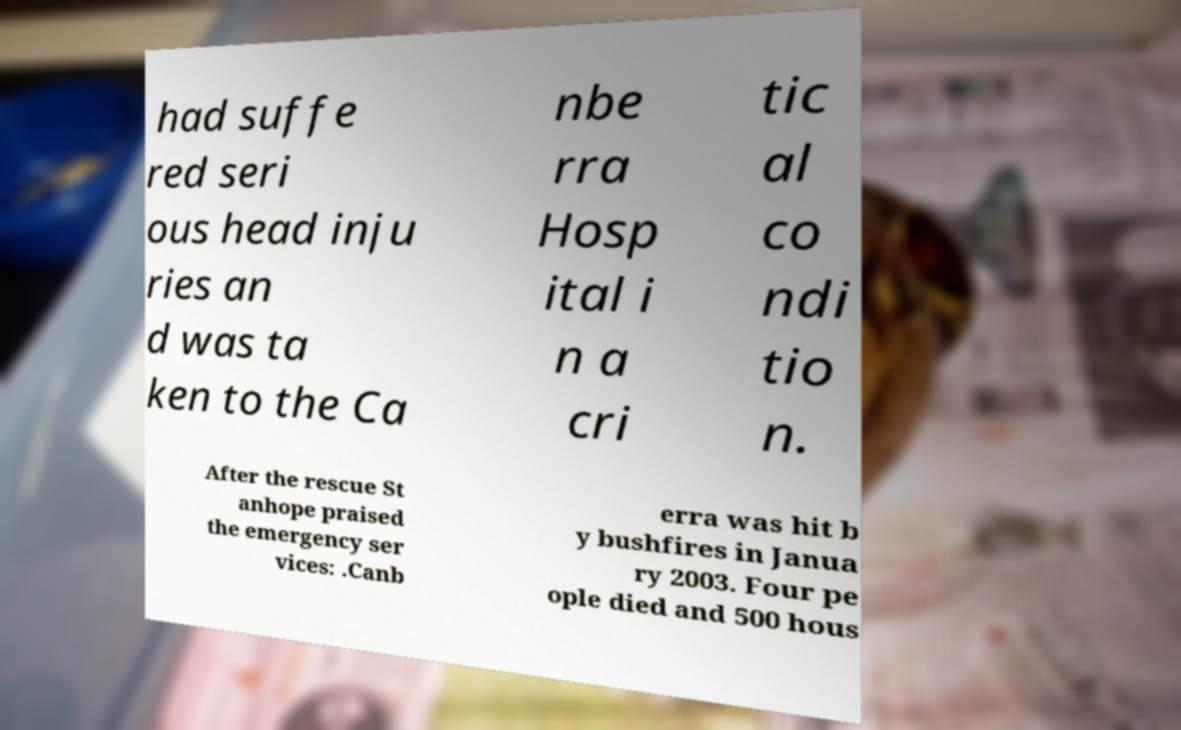What messages or text are displayed in this image? I need them in a readable, typed format. had suffe red seri ous head inju ries an d was ta ken to the Ca nbe rra Hosp ital i n a cri tic al co ndi tio n. After the rescue St anhope praised the emergency ser vices: .Canb erra was hit b y bushfires in Janua ry 2003. Four pe ople died and 500 hous 